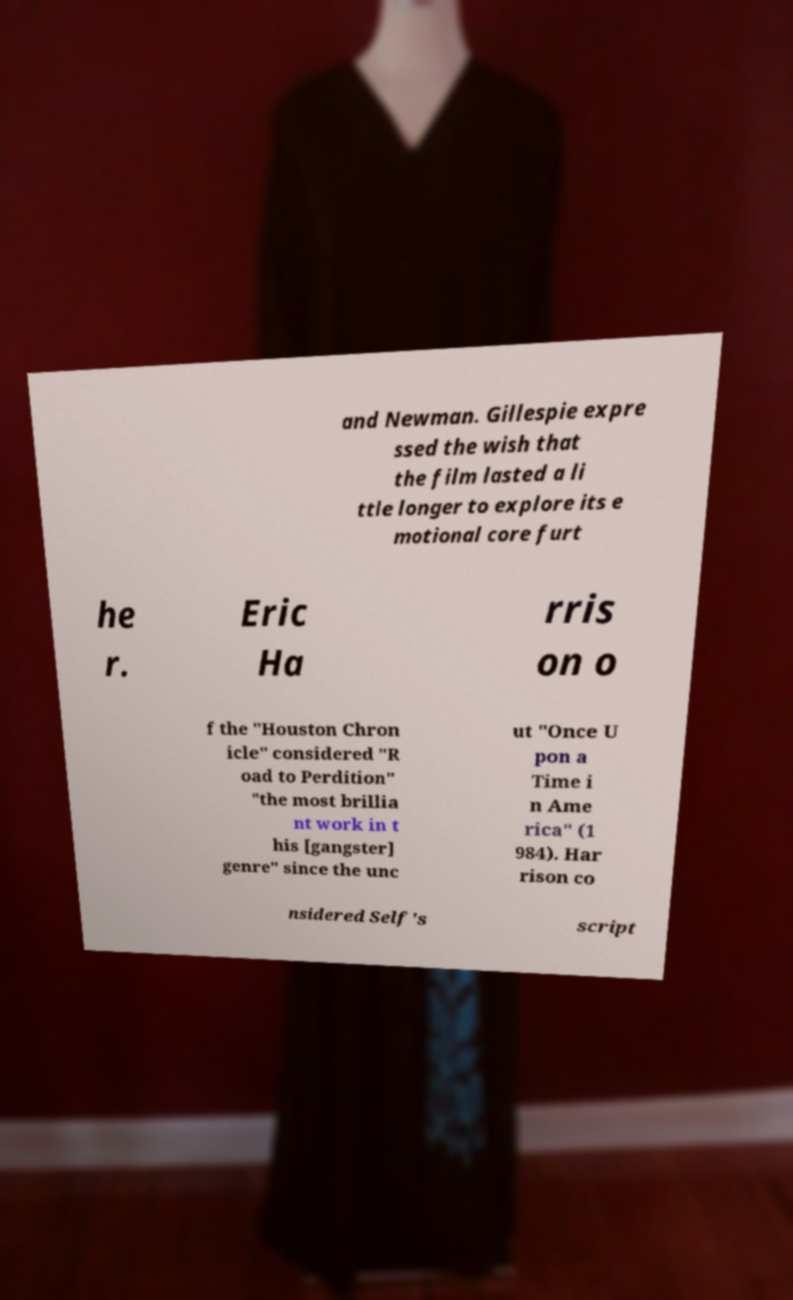Please identify and transcribe the text found in this image. and Newman. Gillespie expre ssed the wish that the film lasted a li ttle longer to explore its e motional core furt he r. Eric Ha rris on o f the "Houston Chron icle" considered "R oad to Perdition" "the most brillia nt work in t his [gangster] genre" since the unc ut "Once U pon a Time i n Ame rica" (1 984). Har rison co nsidered Self's script 